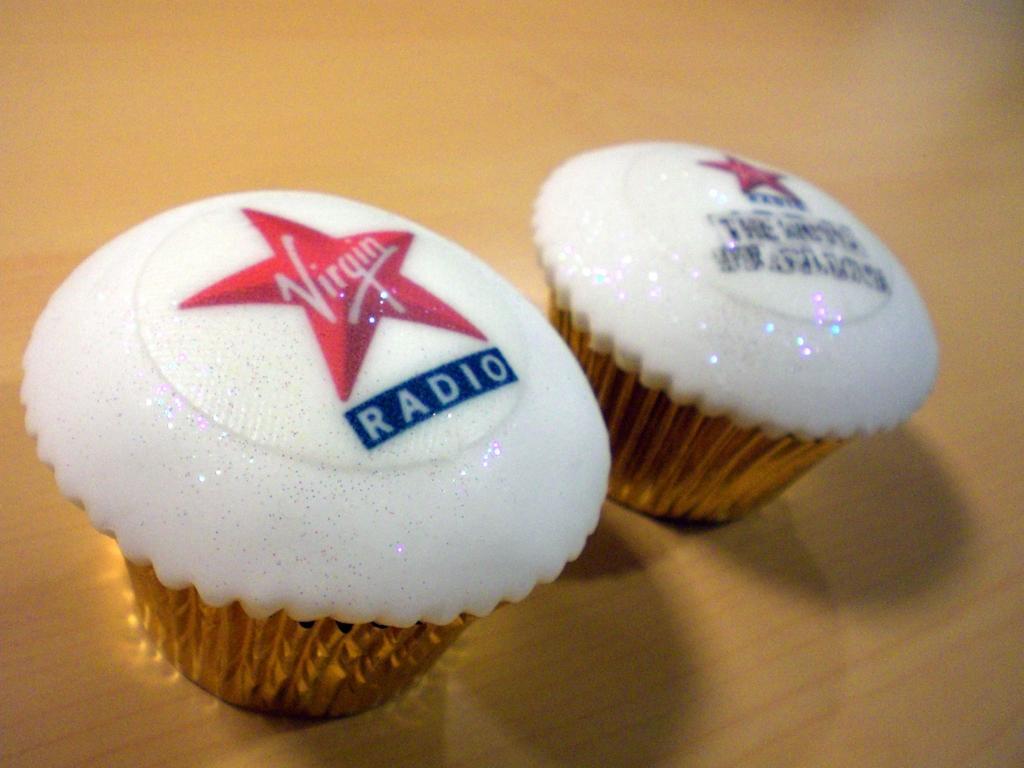How would you summarize this image in a sentence or two? In this image I can see few cupcakes and I can see the red color stars and something is written on it. They are on the brown color surface. 